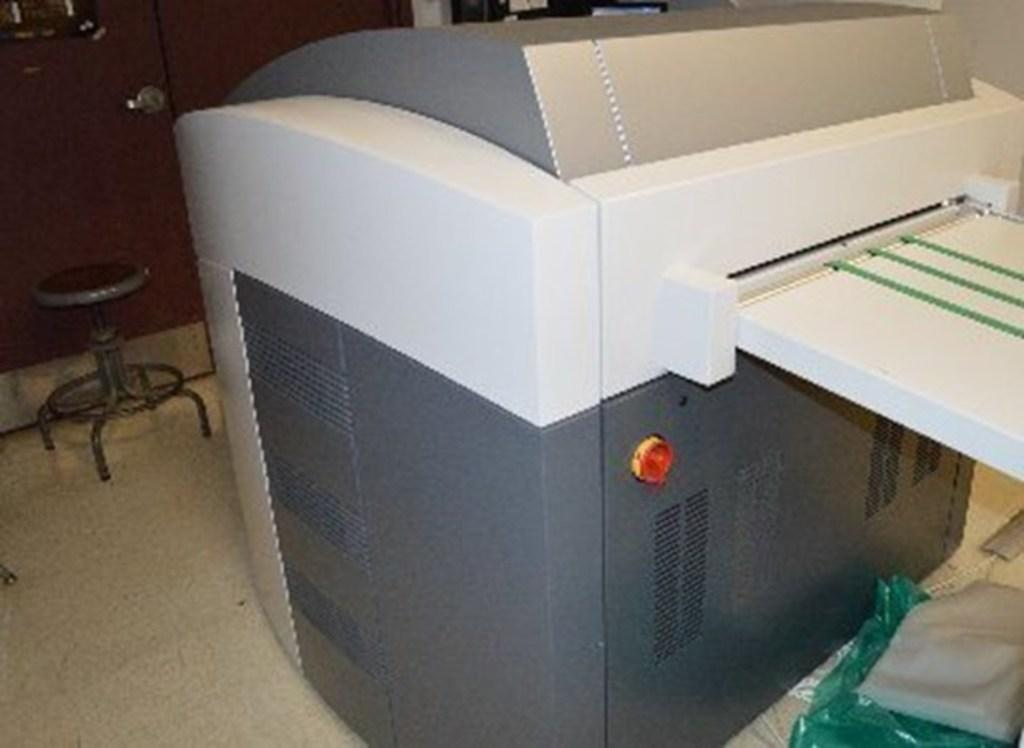What is the main object in the image? There is a printing machine in the image. What type of material is visible in the image? There are polythene covers in the image. Is there any furniture present in the image? Yes, there is a seating stool in the image. What type of structure is present in the image? Walls are present in the image. Can you see a tiger walking down the alley in the image? There is no tiger or alley present in the image. How many fangs does the printing machine have in the image? The printing machine does not have fangs; it is a mechanical device used for printing. 